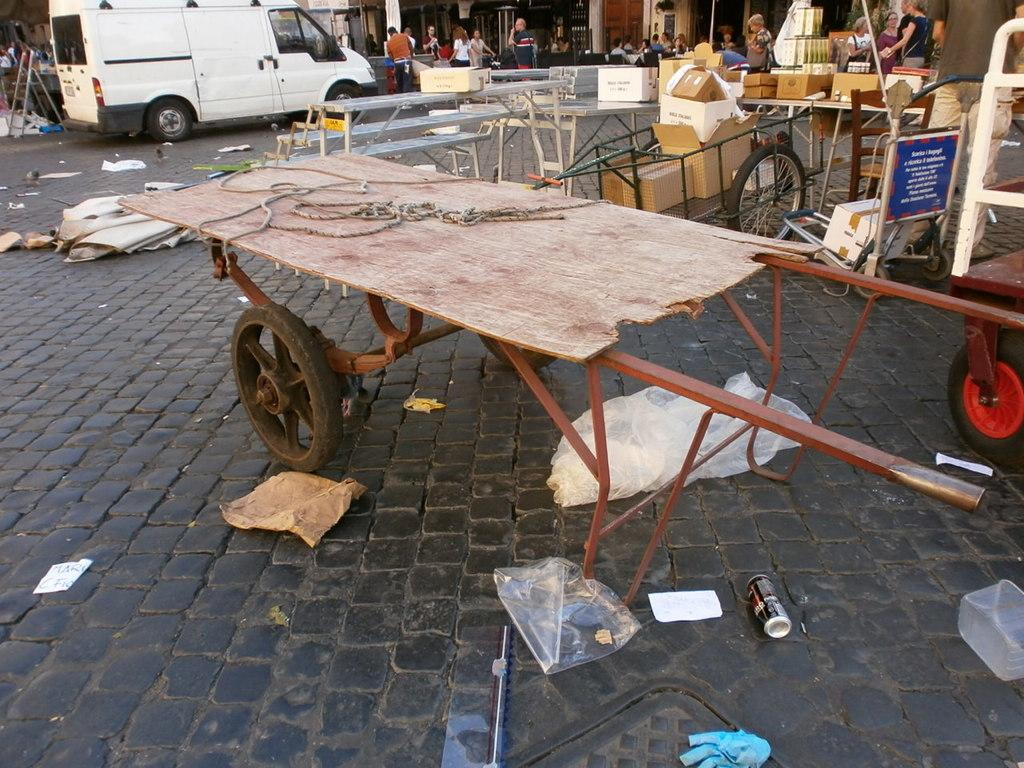What is the main object in the image? There is a cart in the image. What is attached to the cart? There is a thread on the cart. What is on the floor near the cart? There are covers and tins on the floor. Are there any other objects nearby? Yes, there are boxes in the vicinity. Are there people present in the image? Yes, there are people standing nearby. What else can be seen in the image? There is a car in the image. What type of pin can be seen holding the flag in the image? There is no pin or flag present in the image. What is the oven used for in the image? There is no oven present in the image. 